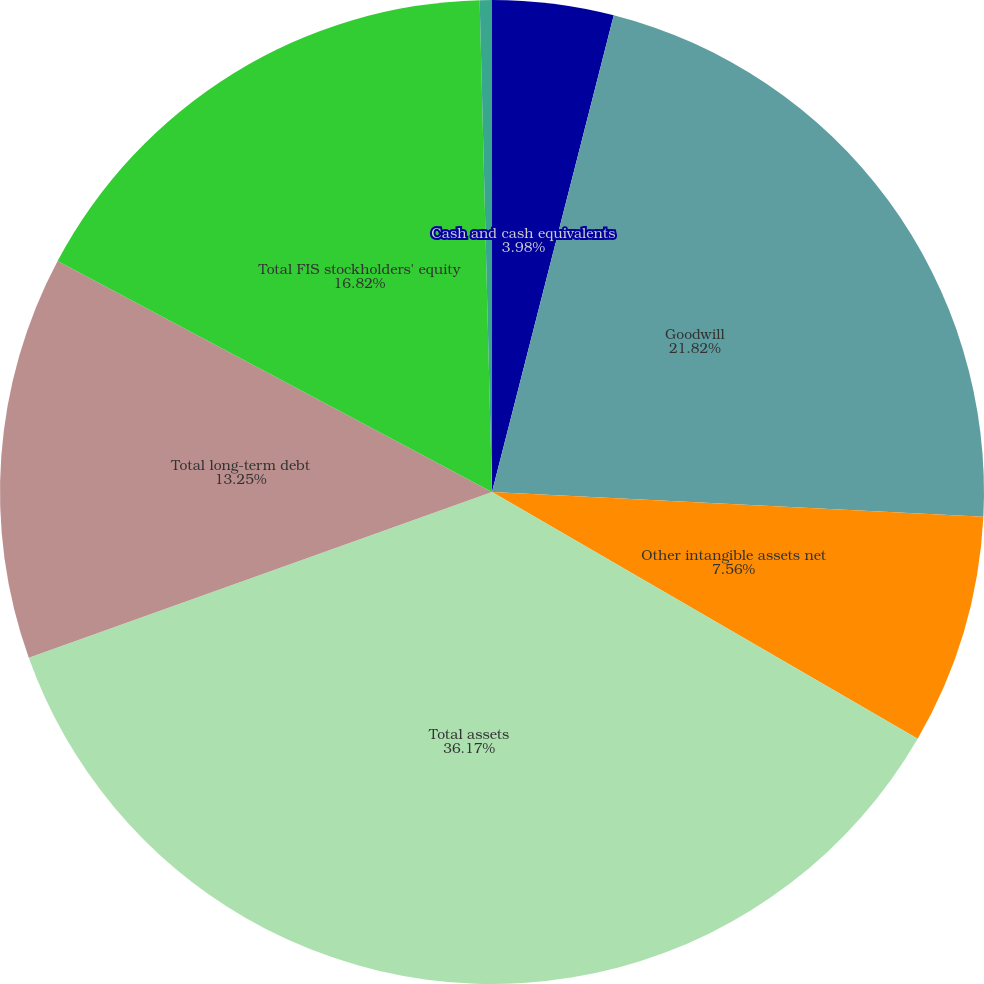Convert chart to OTSL. <chart><loc_0><loc_0><loc_500><loc_500><pie_chart><fcel>Cash and cash equivalents<fcel>Goodwill<fcel>Other intangible assets net<fcel>Total assets<fcel>Total long-term debt<fcel>Total FIS stockholders' equity<fcel>Noncontrolling interest<nl><fcel>3.98%<fcel>21.82%<fcel>7.56%<fcel>36.17%<fcel>13.25%<fcel>16.82%<fcel>0.4%<nl></chart> 